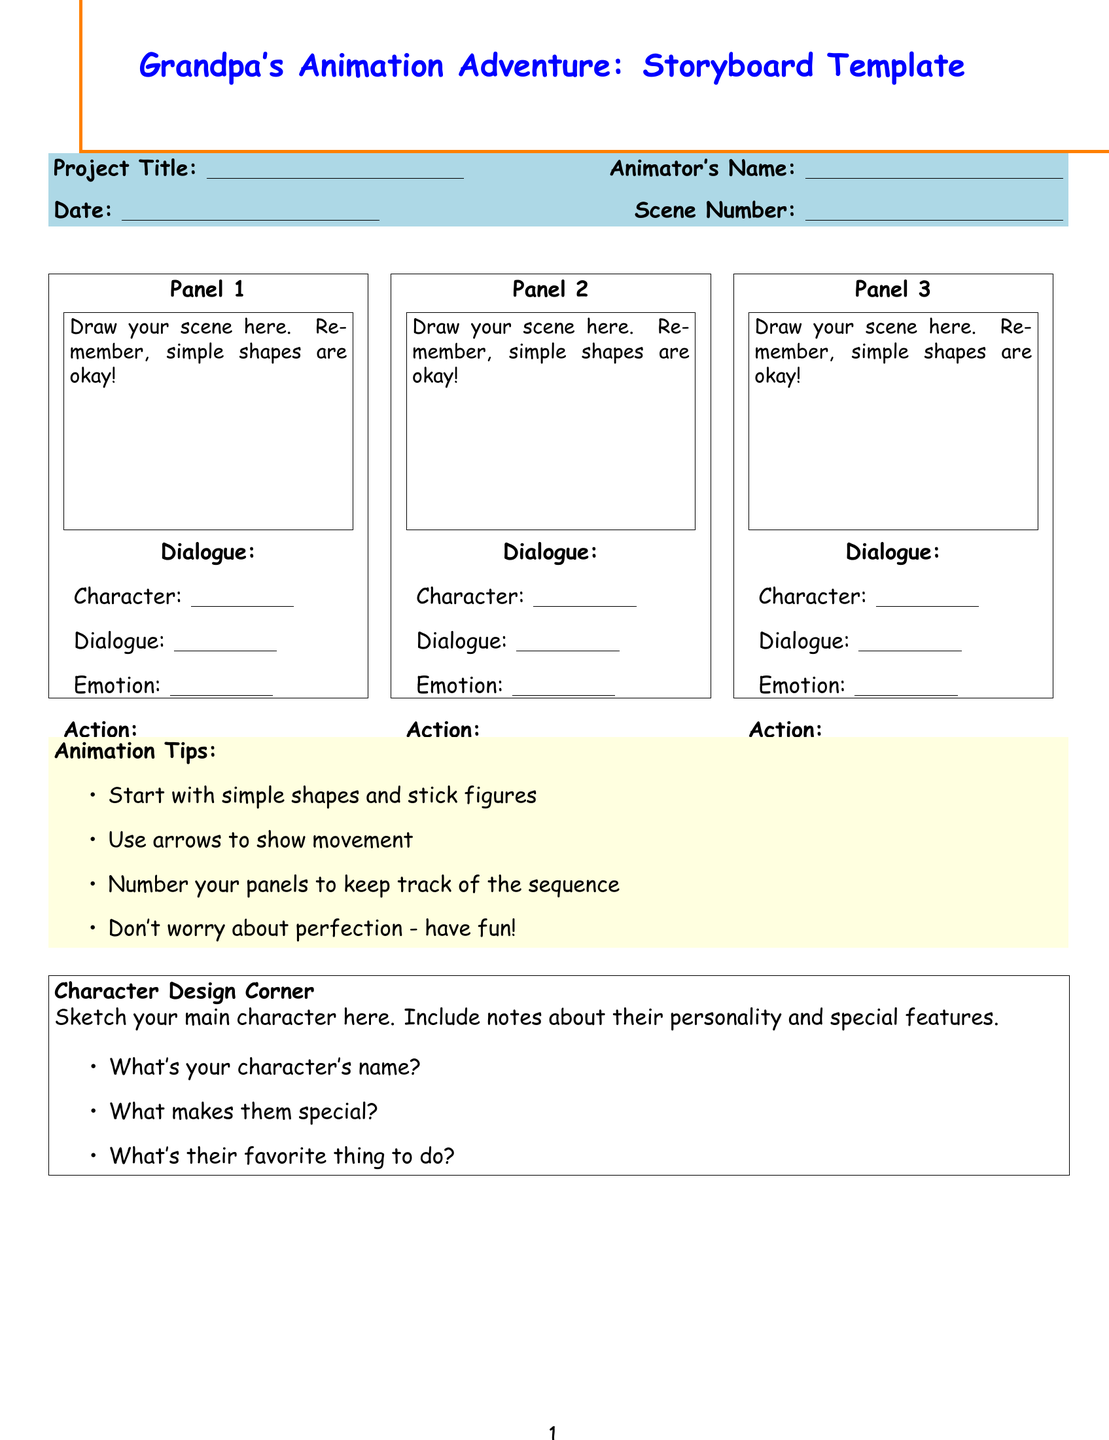What is the title of the storyboard template? The title, located at the top of the document, is the name of the template used for storyboarding animations.
Answer: Grandpa's Animation Adventure: Storyboard Template What is the size of the sketch box in each panel? Each sketch box size is specified within the panels, indicating how much space to use for drawing the scene.
Answer: 4x3 inches What are the first three animation tips listed? The tips are provided in a list format in the document, highlighting important advice for beginner animators.
Answer: Start with simple shapes and stick figures, Use arrows to show movement, Number your panels to keep track of the sequence What is included in the Character Design Corner? The character design section provides prompts for sketching and thinking about the main character's attributes.
Answer: Sketch your main character here. Include notes about their personality and special features What should be written in the Sound Effects and Music box? This section outlines what to consider adding to enhance the animation, particularly auditory elements.
Answer: Write down any sound effects or music you want in your animation What do you need to plan in the Family Viewing Party Planner? The planner section asks for specific details related to the presentation of the finished animation to family.
Answer: Plan when to show your finished animation to the family What is the message of encouragement found at the end of the document? The document concludes with a supportive message aimed at motivating the animator to pursue their creativity.
Answer: I'm so proud of your creativity. Keep it up! 